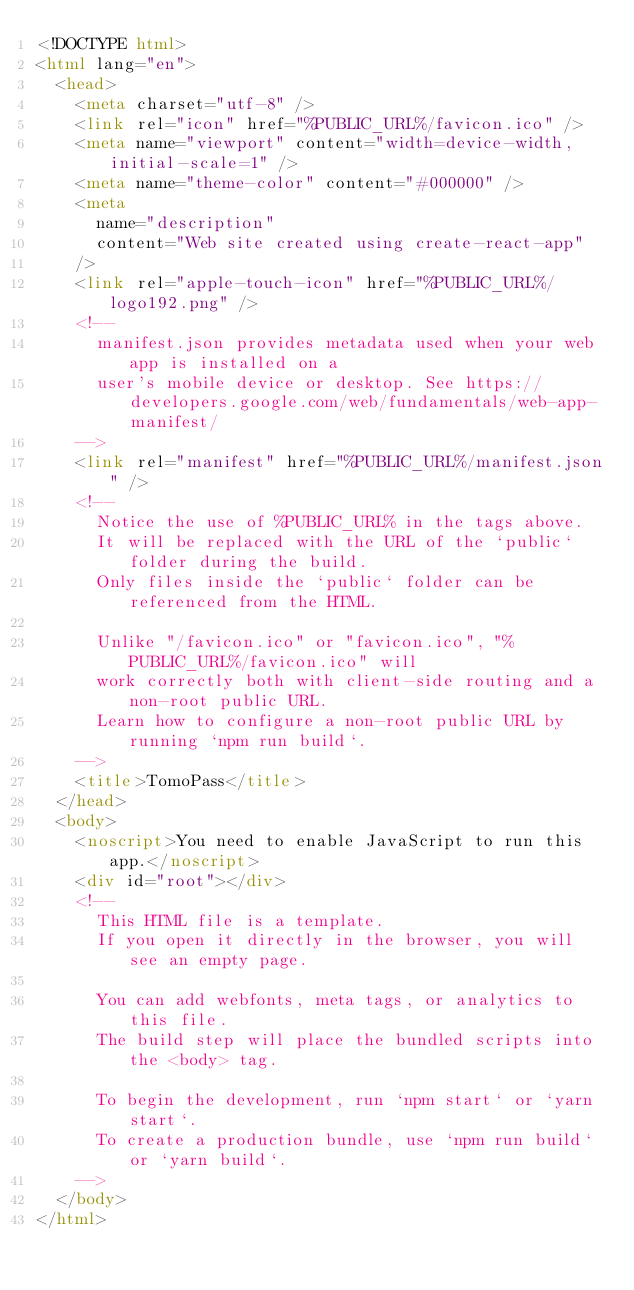Convert code to text. <code><loc_0><loc_0><loc_500><loc_500><_HTML_><!DOCTYPE html>
<html lang="en">
  <head>
    <meta charset="utf-8" />
    <link rel="icon" href="%PUBLIC_URL%/favicon.ico" />
    <meta name="viewport" content="width=device-width, initial-scale=1" />
    <meta name="theme-color" content="#000000" />
    <meta
      name="description"
      content="Web site created using create-react-app"
    />
    <link rel="apple-touch-icon" href="%PUBLIC_URL%/logo192.png" />
    <!--
      manifest.json provides metadata used when your web app is installed on a
      user's mobile device or desktop. See https://developers.google.com/web/fundamentals/web-app-manifest/
    -->
    <link rel="manifest" href="%PUBLIC_URL%/manifest.json" />
    <!--
      Notice the use of %PUBLIC_URL% in the tags above.
      It will be replaced with the URL of the `public` folder during the build.
      Only files inside the `public` folder can be referenced from the HTML.

      Unlike "/favicon.ico" or "favicon.ico", "%PUBLIC_URL%/favicon.ico" will
      work correctly both with client-side routing and a non-root public URL.
      Learn how to configure a non-root public URL by running `npm run build`.
    -->
    <title>TomoPass</title>
  </head>
  <body>
    <noscript>You need to enable JavaScript to run this app.</noscript>
    <div id="root"></div>
    <!--
      This HTML file is a template.
      If you open it directly in the browser, you will see an empty page.

      You can add webfonts, meta tags, or analytics to this file.
      The build step will place the bundled scripts into the <body> tag.

      To begin the development, run `npm start` or `yarn start`.
      To create a production bundle, use `npm run build` or `yarn build`.
    -->
  </body>
</html>
</code> 